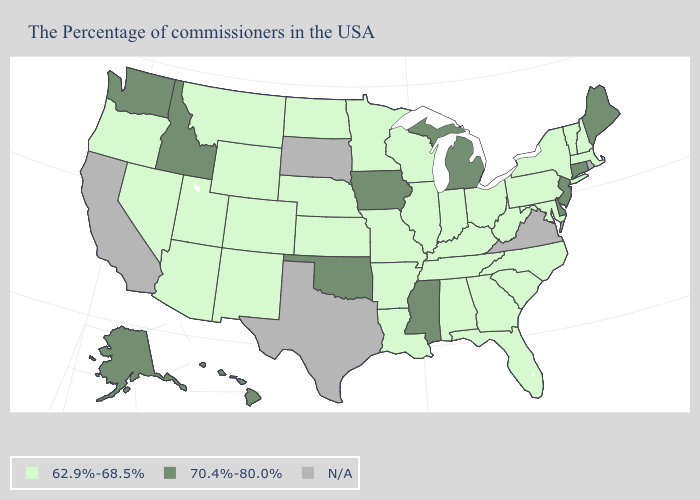Name the states that have a value in the range 62.9%-68.5%?
Concise answer only. Massachusetts, New Hampshire, Vermont, New York, Maryland, Pennsylvania, North Carolina, South Carolina, West Virginia, Ohio, Florida, Georgia, Kentucky, Indiana, Alabama, Tennessee, Wisconsin, Illinois, Louisiana, Missouri, Arkansas, Minnesota, Kansas, Nebraska, North Dakota, Wyoming, Colorado, New Mexico, Utah, Montana, Arizona, Nevada, Oregon. Which states have the lowest value in the South?
Answer briefly. Maryland, North Carolina, South Carolina, West Virginia, Florida, Georgia, Kentucky, Alabama, Tennessee, Louisiana, Arkansas. Name the states that have a value in the range 62.9%-68.5%?
Quick response, please. Massachusetts, New Hampshire, Vermont, New York, Maryland, Pennsylvania, North Carolina, South Carolina, West Virginia, Ohio, Florida, Georgia, Kentucky, Indiana, Alabama, Tennessee, Wisconsin, Illinois, Louisiana, Missouri, Arkansas, Minnesota, Kansas, Nebraska, North Dakota, Wyoming, Colorado, New Mexico, Utah, Montana, Arizona, Nevada, Oregon. What is the value of Oregon?
Concise answer only. 62.9%-68.5%. What is the lowest value in states that border Georgia?
Be succinct. 62.9%-68.5%. Name the states that have a value in the range N/A?
Answer briefly. Rhode Island, Virginia, Texas, South Dakota, California. Does Michigan have the highest value in the MidWest?
Be succinct. Yes. Name the states that have a value in the range N/A?
Concise answer only. Rhode Island, Virginia, Texas, South Dakota, California. Among the states that border New Mexico , does Oklahoma have the lowest value?
Keep it brief. No. What is the lowest value in the USA?
Concise answer only. 62.9%-68.5%. Name the states that have a value in the range N/A?
Quick response, please. Rhode Island, Virginia, Texas, South Dakota, California. Which states have the highest value in the USA?
Short answer required. Maine, Connecticut, New Jersey, Delaware, Michigan, Mississippi, Iowa, Oklahoma, Idaho, Washington, Alaska, Hawaii. Name the states that have a value in the range 70.4%-80.0%?
Concise answer only. Maine, Connecticut, New Jersey, Delaware, Michigan, Mississippi, Iowa, Oklahoma, Idaho, Washington, Alaska, Hawaii. 